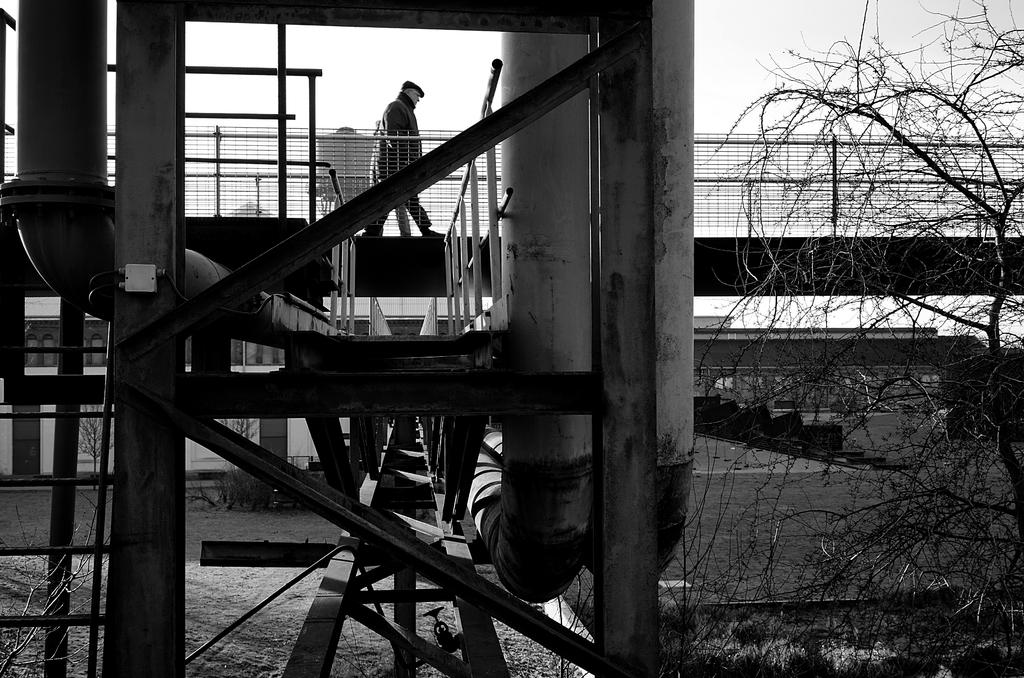What structure is present in the image? There is a bridge in the image. Who or what is on the bridge? There is a person on the bridge. What can be seen in the background of the image? There are trees and the sky visible in the background of the image. How long does it take for the eggnog to flow under the bridge in the image? There is no eggnog present in the image, and therefore it cannot flow under the bridge. 